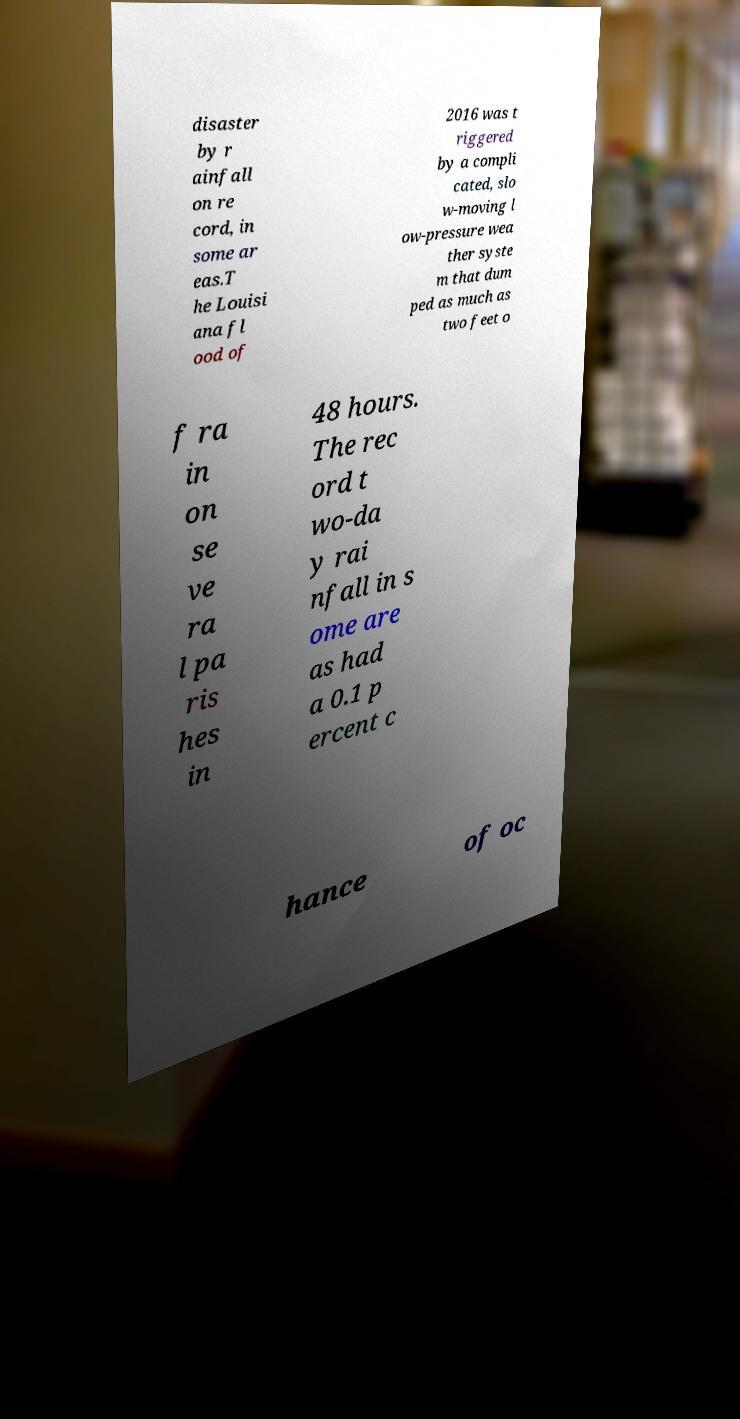There's text embedded in this image that I need extracted. Can you transcribe it verbatim? disaster by r ainfall on re cord, in some ar eas.T he Louisi ana fl ood of 2016 was t riggered by a compli cated, slo w-moving l ow-pressure wea ther syste m that dum ped as much as two feet o f ra in on se ve ra l pa ris hes in 48 hours. The rec ord t wo-da y rai nfall in s ome are as had a 0.1 p ercent c hance of oc 